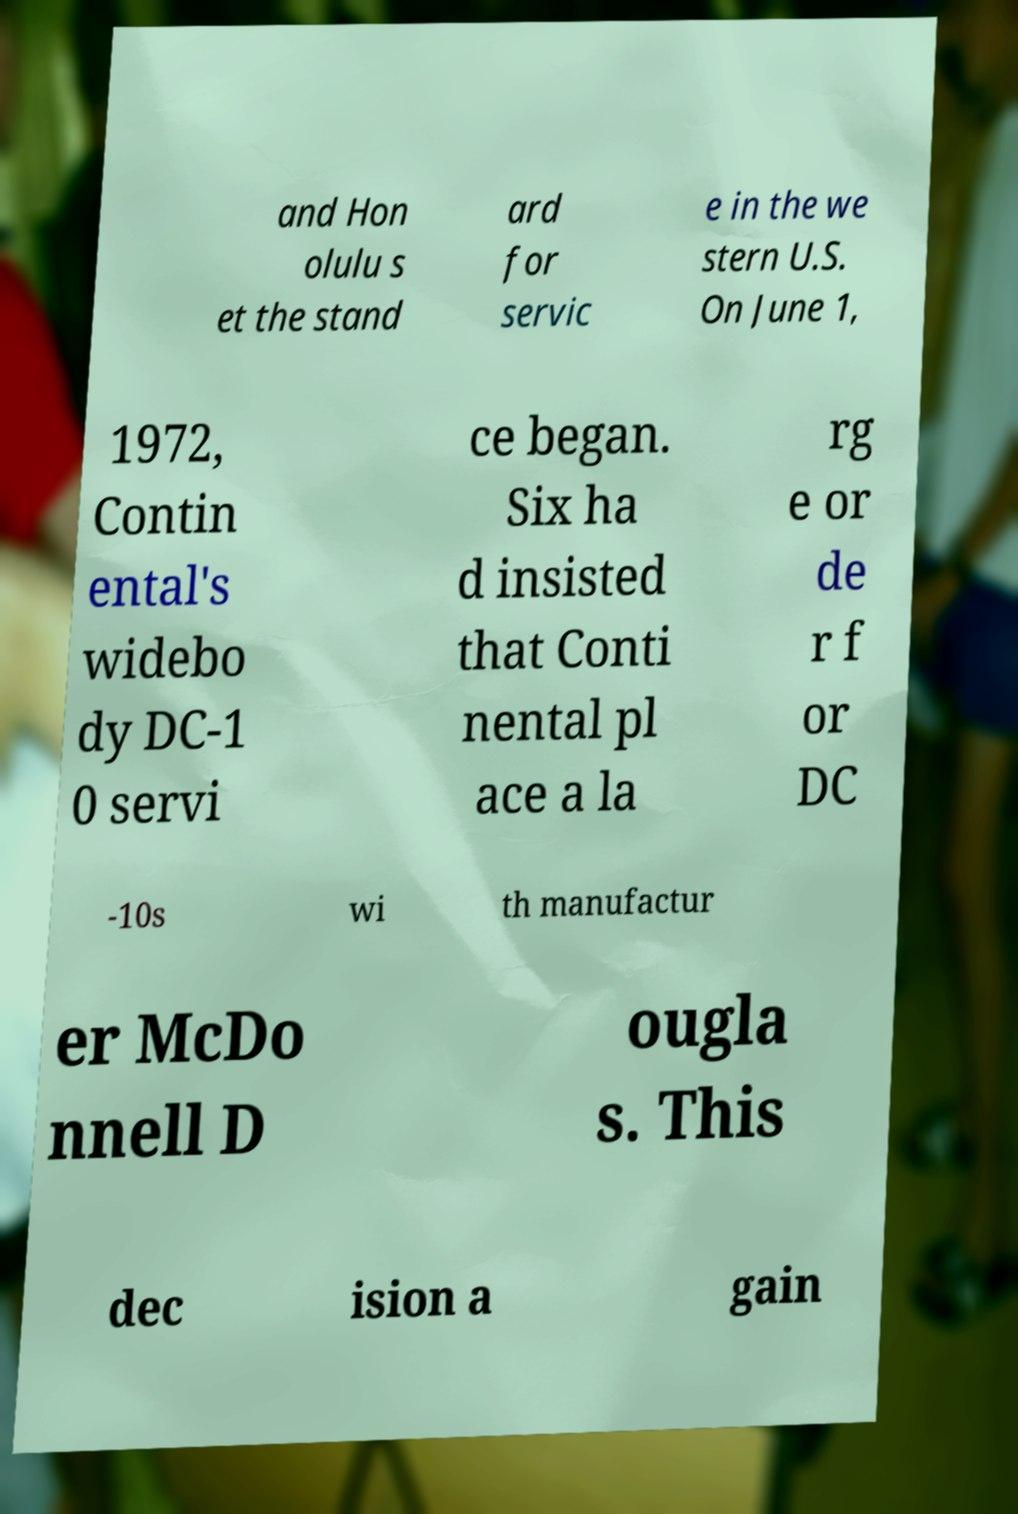Could you assist in decoding the text presented in this image and type it out clearly? and Hon olulu s et the stand ard for servic e in the we stern U.S. On June 1, 1972, Contin ental's widebo dy DC-1 0 servi ce began. Six ha d insisted that Conti nental pl ace a la rg e or de r f or DC -10s wi th manufactur er McDo nnell D ougla s. This dec ision a gain 